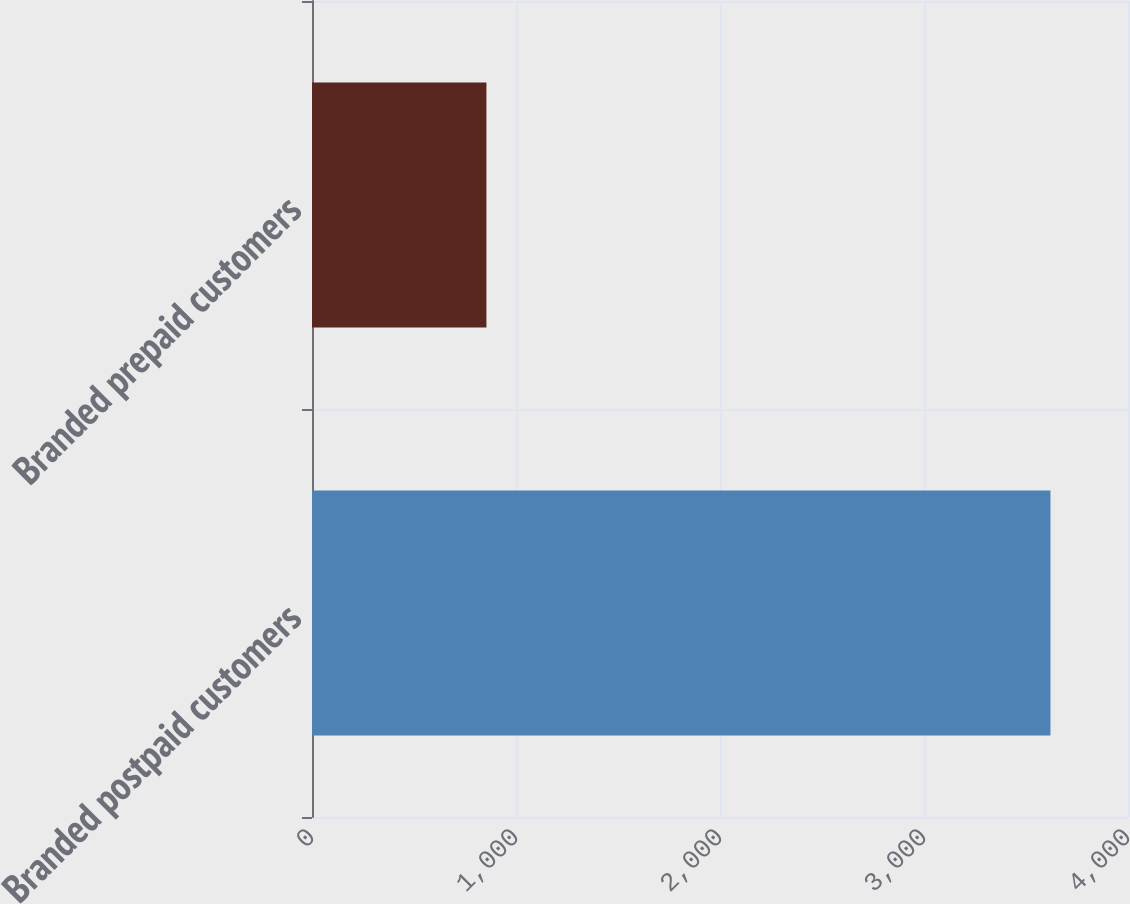Convert chart to OTSL. <chart><loc_0><loc_0><loc_500><loc_500><bar_chart><fcel>Branded postpaid customers<fcel>Branded prepaid customers<nl><fcel>3620<fcel>855<nl></chart> 